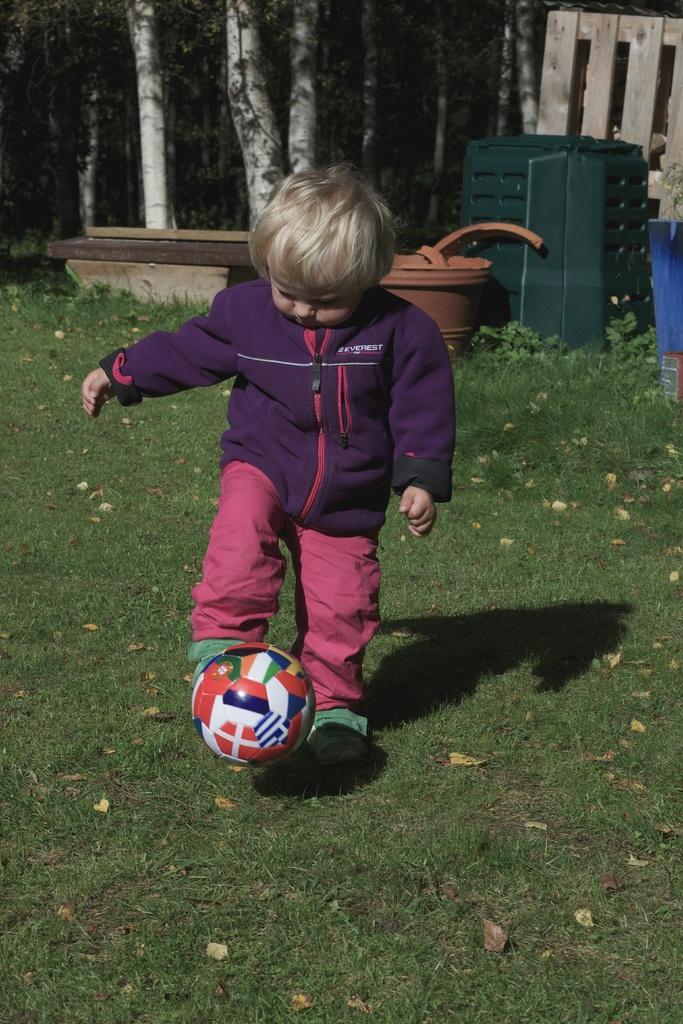In one or two sentences, can you explain what this image depicts? In this picture there is a kid who is playing with a football. On the bottom there is a grass. On the top right corner there is a wooden fencing and some objects. Here we can see a pot. On top left corner we can see a trees. 